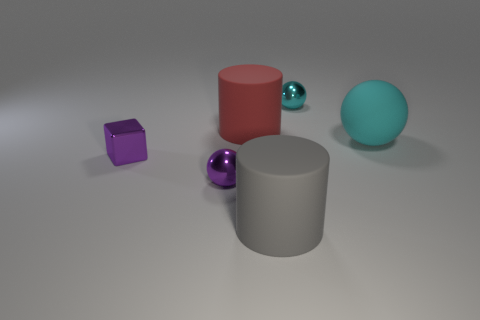Are there fewer cylinders than brown rubber spheres?
Give a very brief answer. No. Does the large cylinder in front of the metallic cube have the same color as the matte sphere?
Provide a succinct answer. No. There is a cyan sphere that is in front of the cyan ball that is behind the big red matte object; what number of big cyan spheres are to the left of it?
Offer a very short reply. 0. There is a small cyan shiny sphere; how many tiny purple balls are behind it?
Offer a very short reply. 0. What color is the other big matte object that is the same shape as the large gray matte thing?
Keep it short and to the point. Red. There is a thing that is both in front of the large cyan object and to the right of the purple metallic sphere; what material is it made of?
Your response must be concise. Rubber. Does the metal ball that is left of the gray object have the same size as the purple cube?
Your answer should be compact. Yes. What material is the tiny cube?
Give a very brief answer. Metal. There is a tiny ball that is to the right of the gray matte thing; what color is it?
Provide a succinct answer. Cyan. What number of big objects are purple shiny cylinders or gray matte things?
Keep it short and to the point. 1. 